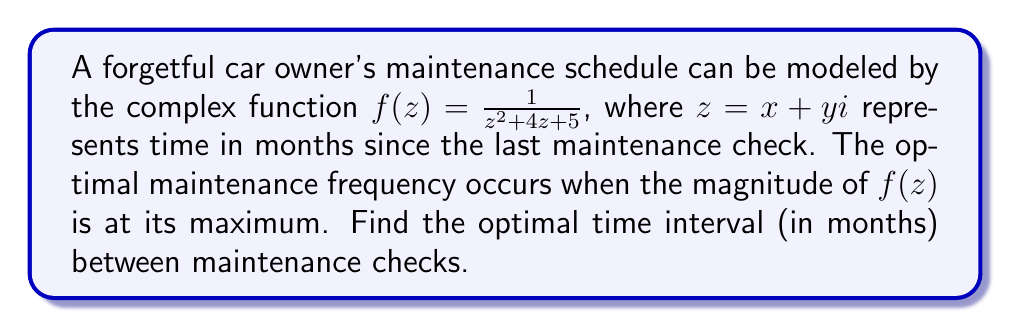Can you answer this question? To solve this problem, we need to follow these steps:

1) The magnitude of a complex function $f(z) = \frac{1}{z^2 + 4z + 5}$ is given by $|f(z)| = \frac{1}{|z^2 + 4z + 5|}$.

2) The maximum of $|f(z)|$ occurs when $|z^2 + 4z + 5|$ is at its minimum.

3) Let's complete the square for the denominator:
   $z^2 + 4z + 5 = (z^2 + 4z + 4) + 1 = (z + 2)^2 + 1$

4) The magnitude of this expression is:
   $|(z + 2)^2 + 1| = \sqrt{((x+2)^2 - y^2 + 1)^2 + (2(x+2)y)^2}$

5) This expression is minimized when $z = -2$, or when $x = -2$ and $y = 0$.

6) At this point, the denominator equals 1, giving the maximum value of $|f(z)|$.

7) Since $z$ represents time in months, and we're interested in the positive time interval, we take the absolute value of the real part of $z$.

Therefore, the optimal time interval between maintenance checks is $|-2| = 2$ months.
Answer: 2 months 